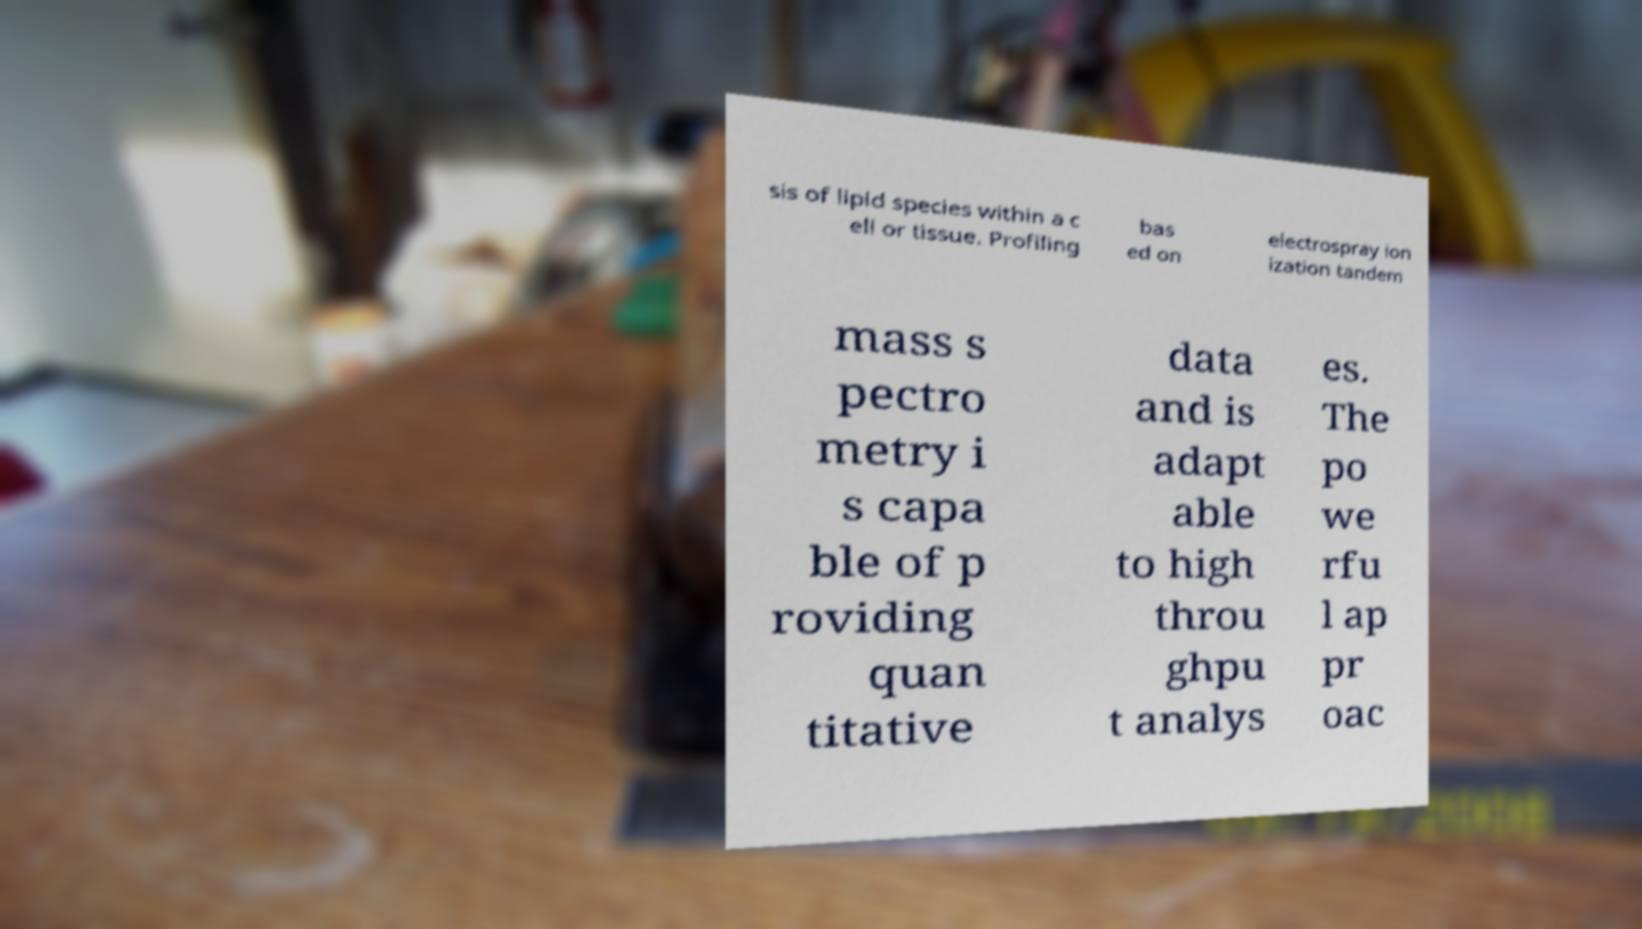Could you assist in decoding the text presented in this image and type it out clearly? sis of lipid species within a c ell or tissue. Profiling bas ed on electrospray ion ization tandem mass s pectro metry i s capa ble of p roviding quan titative data and is adapt able to high throu ghpu t analys es. The po we rfu l ap pr oac 